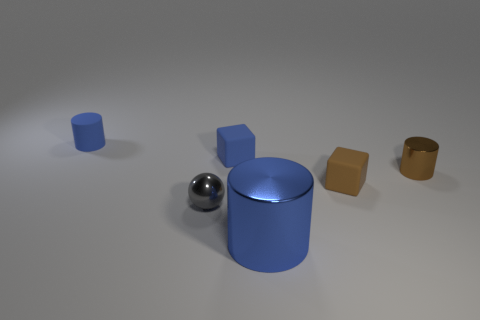The other cylinder that is the same color as the large cylinder is what size?
Your response must be concise. Small. Is the size of the brown rubber cube the same as the metal ball?
Provide a succinct answer. Yes. There is a metallic cylinder behind the small gray metallic object; what is its color?
Give a very brief answer. Brown. Is there a shiny object of the same color as the small rubber cylinder?
Offer a very short reply. Yes. There is a rubber cylinder that is the same size as the blue matte block; what color is it?
Offer a very short reply. Blue. Do the blue metallic thing and the tiny gray thing have the same shape?
Make the answer very short. No. There is a thing in front of the ball; what is it made of?
Ensure brevity in your answer.  Metal. What color is the tiny ball?
Your answer should be very brief. Gray. Do the blue thing in front of the small brown metal cylinder and the block behind the brown metal cylinder have the same size?
Give a very brief answer. No. How big is the object that is both right of the large blue cylinder and to the left of the small brown cylinder?
Provide a succinct answer. Small. 